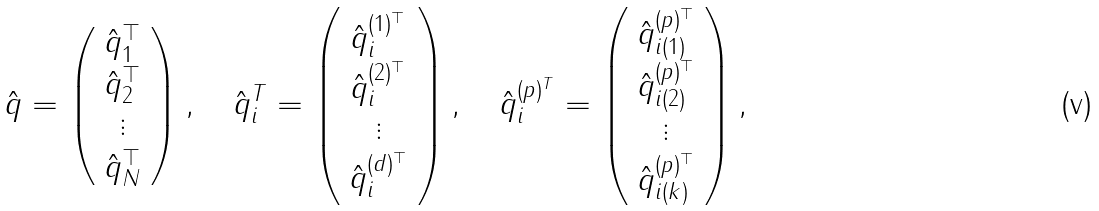Convert formula to latex. <formula><loc_0><loc_0><loc_500><loc_500>\hat { q } = \left ( \begin{array} { c } \hat { q } _ { 1 } ^ { \top } \\ \hat { q } _ { 2 } ^ { \top } \\ \vdots \\ \hat { q } _ { N } ^ { \top } \\ \end{array} \right ) , \quad \hat { q } _ { i } ^ { T } = \left ( \begin{array} { c } \hat { q } _ { i } ^ { ( 1 ) ^ { \top } } \\ \hat { q } _ { i } ^ { ( 2 ) ^ { \top } } \\ \vdots \\ \hat { q } _ { i } ^ { ( d ) ^ { \top } } \\ \end{array} \right ) , \quad \hat { q } _ { i } ^ { ( p ) ^ { T } } = \left ( \begin{array} { c } \hat { q } _ { i ( 1 ) } ^ { ( p ) ^ { \top } } \\ \hat { q } _ { i ( 2 ) } ^ { ( p ) ^ { \top } } \\ \vdots \\ \hat { q } _ { i ( k ) } ^ { ( p ) ^ { \top } } \\ \end{array} \right ) ,</formula> 